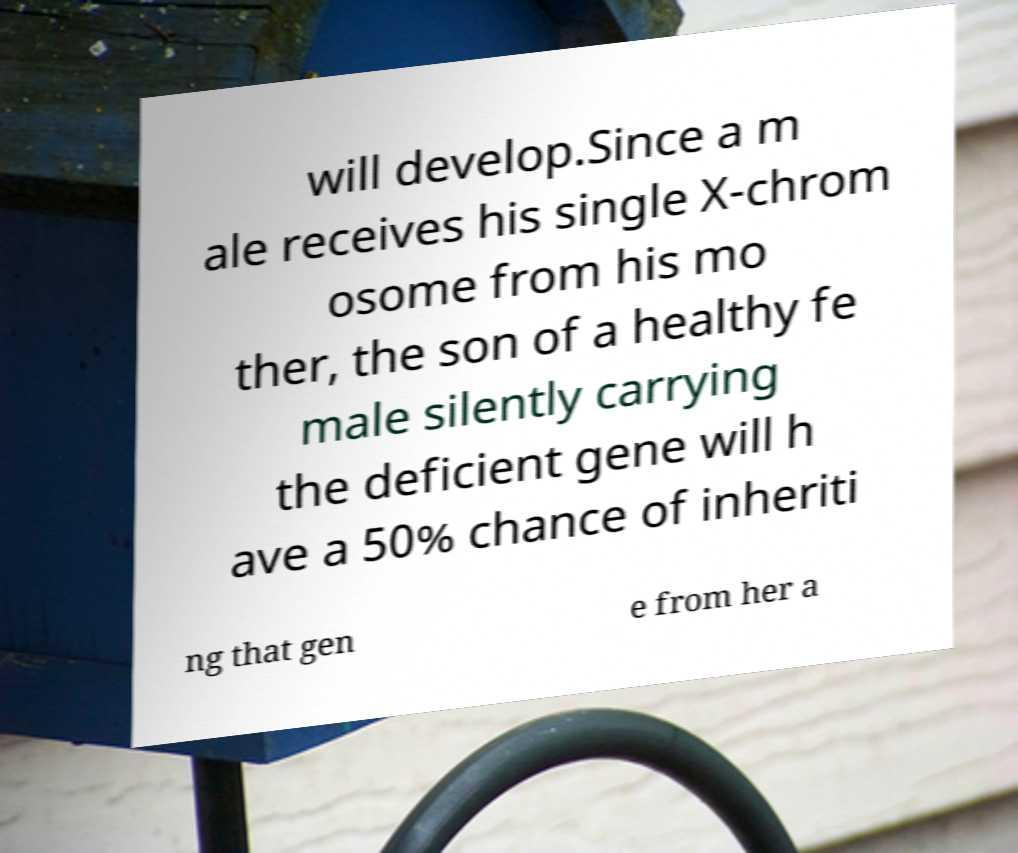Please identify and transcribe the text found in this image. will develop.Since a m ale receives his single X-chrom osome from his mo ther, the son of a healthy fe male silently carrying the deficient gene will h ave a 50% chance of inheriti ng that gen e from her a 